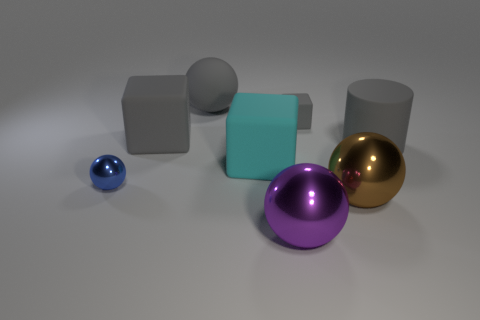Subtract all brown spheres. How many spheres are left? 3 Subtract all tiny metallic balls. How many balls are left? 3 Subtract all green spheres. Subtract all gray blocks. How many spheres are left? 4 Add 2 gray matte cubes. How many objects exist? 10 Subtract all cylinders. How many objects are left? 7 Subtract 0 yellow cylinders. How many objects are left? 8 Subtract all small balls. Subtract all large purple metal spheres. How many objects are left? 6 Add 5 large gray matte things. How many large gray matte things are left? 8 Add 3 tiny green metallic things. How many tiny green metallic things exist? 3 